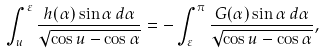<formula> <loc_0><loc_0><loc_500><loc_500>\int _ { u } ^ { \varepsilon } \frac { h ( \alpha ) \sin \alpha \, d \alpha } { \sqrt { \cos u - \cos \alpha } } = - \int _ { \varepsilon } ^ { \pi } \frac { G ( \alpha ) \sin \alpha \, d \alpha } { \sqrt { \cos u - \cos \alpha } } ,</formula> 